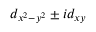<formula> <loc_0><loc_0><loc_500><loc_500>d _ { x ^ { 2 } - y ^ { 2 } } \pm i d _ { x y }</formula> 